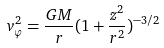<formula> <loc_0><loc_0><loc_500><loc_500>v _ { \varphi } ^ { 2 } = \frac { G M } { r } ( 1 + \frac { z ^ { 2 } } { r ^ { 2 } } ) ^ { - 3 / 2 }</formula> 